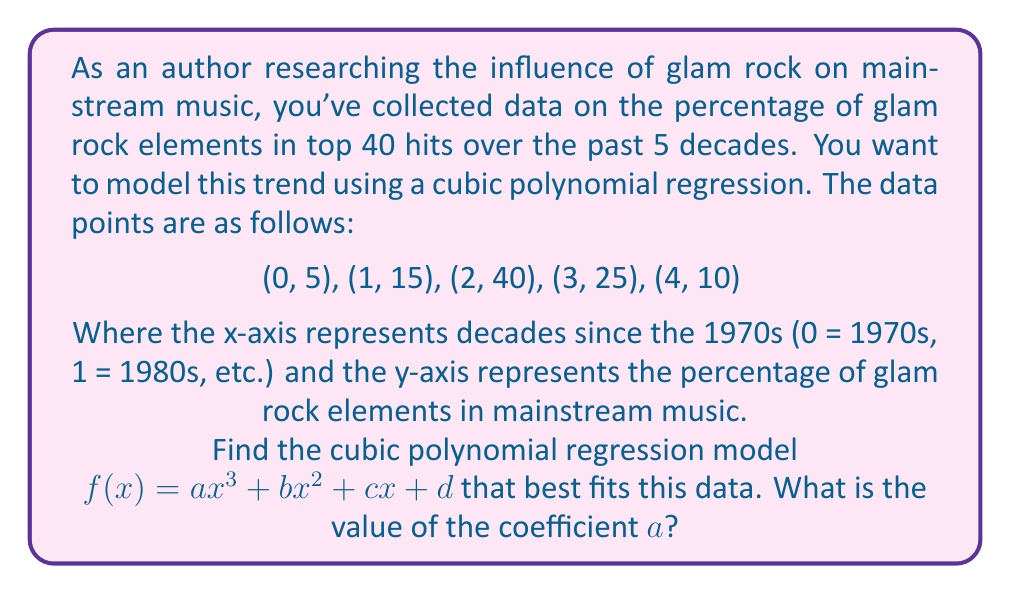Provide a solution to this math problem. To find the cubic polynomial regression model, we need to solve a system of equations using the normal equations method. For a cubic model $f(x) = ax^3 + bx^2 + cx + d$, we have:

$$\begin{bmatrix}
\sum x^6 & \sum x^5 & \sum x^4 & \sum x^3 \\
\sum x^5 & \sum x^4 & \sum x^3 & \sum x^2 \\
\sum x^4 & \sum x^3 & \sum x^2 & \sum x \\
\sum x^3 & \sum x^2 & \sum x & n
\end{bmatrix}
\begin{bmatrix}
a \\
b \\
c \\
d
\end{bmatrix} =
\begin{bmatrix}
\sum yx^3 \\
\sum yx^2 \\
\sum yx \\
\sum y
\end{bmatrix}$$

Let's calculate the sums:

$\sum x^6 = 0^6 + 1^6 + 2^6 + 3^6 + 4^6 = 2275$
$\sum x^5 = 0^5 + 1^5 + 2^5 + 3^5 + 4^5 = 624$
$\sum x^4 = 0^4 + 1^4 + 2^4 + 3^4 + 4^4 = 194$
$\sum x^3 = 0^3 + 1^3 + 2^3 + 3^3 + 4^3 = 100$
$\sum x^2 = 0^2 + 1^2 + 2^2 + 3^2 + 4^2 = 30$
$\sum x = 0 + 1 + 2 + 3 + 4 = 10$
$n = 5$

$\sum yx^3 = 5(0^3) + 15(1^3) + 40(2^3) + 25(3^3) + 10(4^3) = 1660$
$\sum yx^2 = 5(0^2) + 15(1^2) + 40(2^2) + 25(3^2) + 10(4^2) = 530$
$\sum yx = 5(0) + 15(1) + 40(2) + 25(3) + 10(4) = 220$
$\sum y = 5 + 15 + 40 + 25 + 10 = 95$

Now we can set up the system of equations:

$$\begin{bmatrix}
2275 & 624 & 194 & 100 \\
624 & 194 & 100 & 30 \\
194 & 100 & 30 & 10 \\
100 & 30 & 10 & 5
\end{bmatrix}
\begin{bmatrix}
a \\
b \\
c \\
d
\end{bmatrix} =
\begin{bmatrix}
1660 \\
530 \\
220 \\
95
\end{bmatrix}$$

Solving this system of equations (using a computer algebra system or matrix operations) yields:

$$\begin{bmatrix}
a \\
b \\
c \\
d
\end{bmatrix} =
\begin{bmatrix}
-5 \\
15 \\
10 \\
5
\end{bmatrix}$$

Therefore, the cubic polynomial regression model is:

$f(x) = -5x^3 + 15x^2 + 10x + 5$

The coefficient $a$ is -5.
Answer: $a = -5$ 